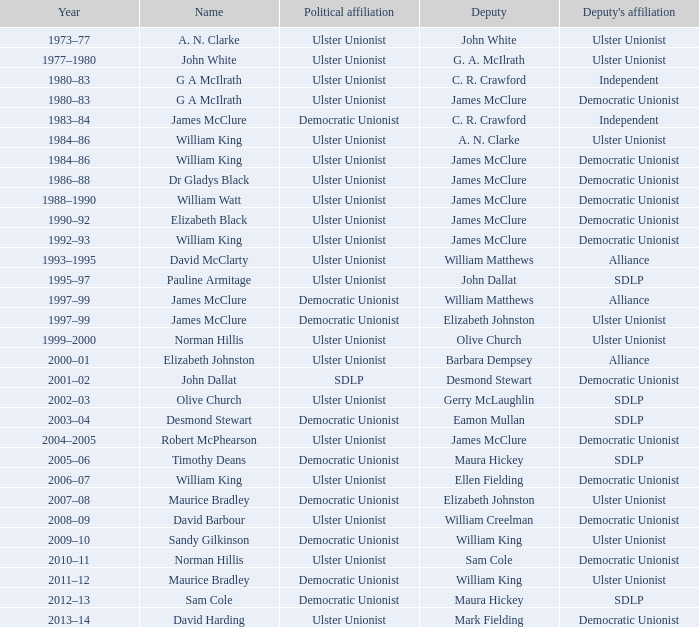What is the name of the Deputy when the Name was elizabeth black? James McClure. 